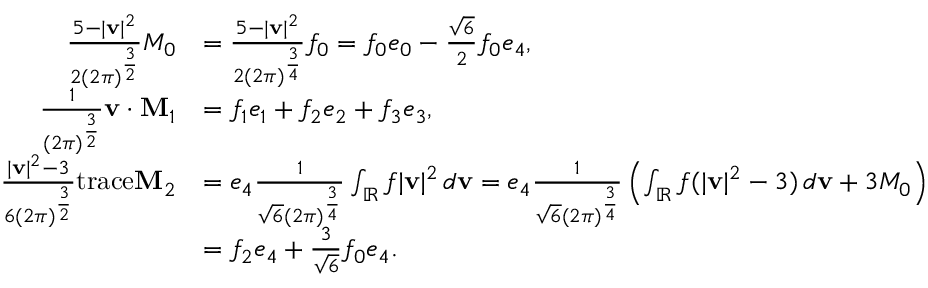<formula> <loc_0><loc_0><loc_500><loc_500>\begin{array} { r l } { \frac { 5 - | v | ^ { 2 } } { 2 ( 2 \pi ) ^ { \frac { 3 } { 2 } } } M _ { 0 } } & { = \frac { 5 - | v | ^ { 2 } } { 2 ( 2 \pi ) ^ { \frac { 3 } { 4 } } } f _ { 0 } = f _ { 0 } e _ { 0 } - \frac { \sqrt { 6 } } { 2 } f _ { 0 } e _ { 4 } , } \\ { \frac { 1 } { ( 2 \pi ) ^ { \frac { 3 } { 2 } } } v \cdot M _ { 1 } } & { = f _ { 1 } e _ { 1 } + f _ { 2 } e _ { 2 } + f _ { 3 } e _ { 3 } , } \\ { \frac { | v | ^ { 2 } - 3 } { 6 ( 2 \pi ) ^ { \frac { 3 } { 2 } } } t r a c e M _ { 2 } } & { = e _ { 4 } \frac { 1 } { \sqrt { 6 } ( 2 \pi ) ^ { \frac { 3 } { 4 } } } \int _ { \mathbb { R } } f | v | ^ { 2 } \, d v = e _ { 4 } \frac { 1 } { \sqrt { 6 } ( 2 \pi ) ^ { \frac { 3 } { 4 } } } \left ( \int _ { \mathbb { R } } f ( | v | ^ { 2 } - 3 ) \, d v + 3 M _ { 0 } \right ) } \\ & { = f _ { 2 } e _ { 4 } + \frac { 3 } { \sqrt { 6 } } f _ { 0 } e _ { 4 } . } \end{array}</formula> 